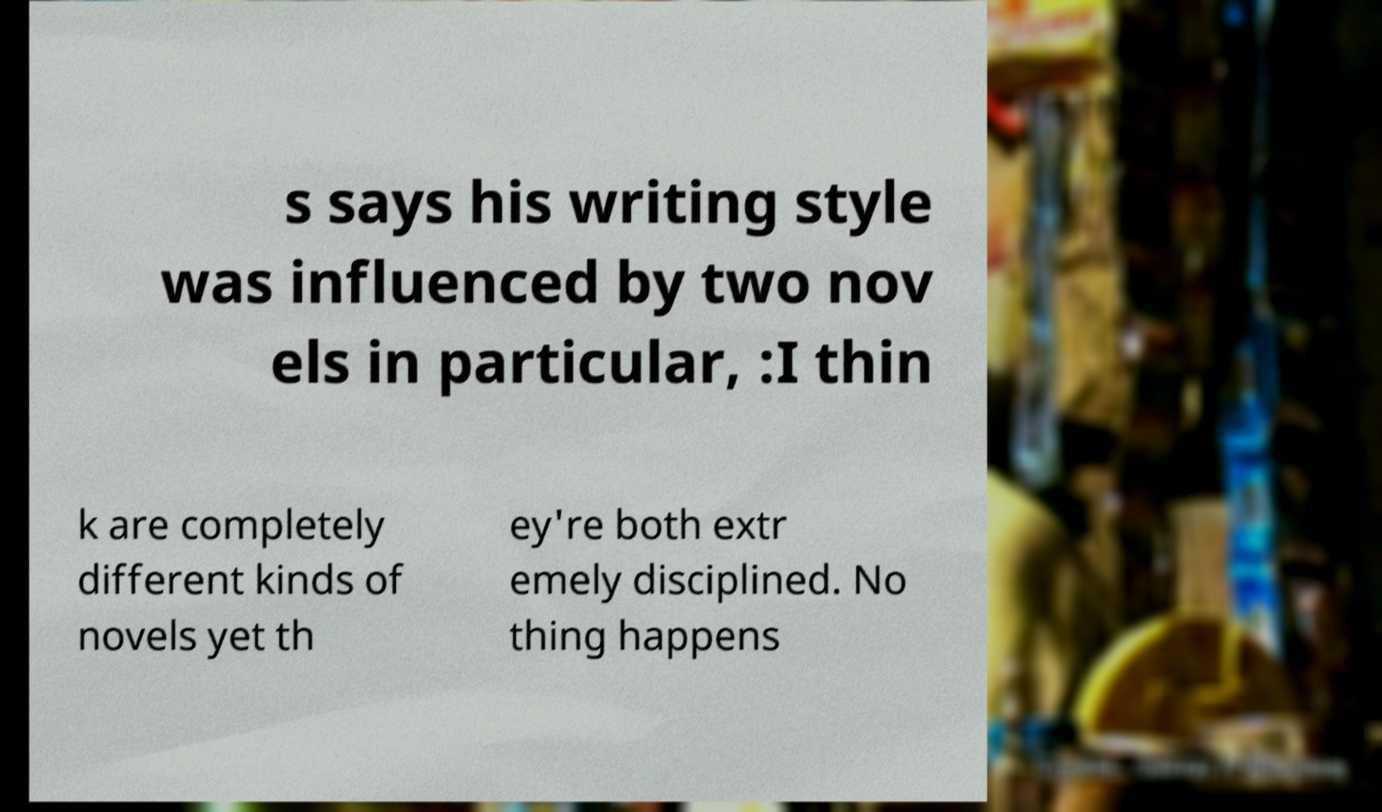Please read and relay the text visible in this image. What does it say? s says his writing style was influenced by two nov els in particular, :I thin k are completely different kinds of novels yet th ey're both extr emely disciplined. No thing happens 